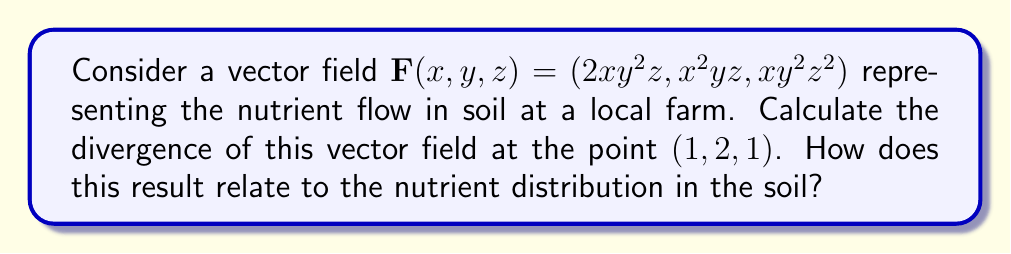Solve this math problem. To solve this problem, we'll follow these steps:

1) The divergence of a vector field $\mathbf{F}(x, y, z) = (F_1, F_2, F_3)$ is given by:

   $$\nabla \cdot \mathbf{F} = \frac{\partial F_1}{\partial x} + \frac{\partial F_2}{\partial y} + \frac{\partial F_3}{\partial z}$$

2) For our vector field $\mathbf{F}(x, y, z) = (2xy^2z, x^2yz, xy^2z^2)$, we need to calculate:

   $$\frac{\partial}{\partial x}(2xy^2z) + \frac{\partial}{\partial y}(x^2yz) + \frac{\partial}{\partial z}(xy^2z^2)$$

3) Let's calculate each partial derivative:

   $\frac{\partial}{\partial x}(2xy^2z) = 2y^2z$
   
   $\frac{\partial}{\partial y}(x^2yz) = x^2z$
   
   $\frac{\partial}{\partial z}(xy^2z^2) = 2xy^2z$

4) Now, we can write the divergence as:

   $$\nabla \cdot \mathbf{F} = 2y^2z + x^2z + 2xy^2z$$

5) To evaluate this at the point $(1, 2, 1)$, we substitute $x=1$, $y=2$, and $z=1$:

   $$\nabla \cdot \mathbf{F}|_{(1,2,1)} = 2(2^2)(1) + (1^2)(1) + 2(1)(2^2)(1) = 8 + 1 + 8 = 17$$

6) Interpretation: The positive divergence indicates that this point is a source of nutrients in the soil. This means that at this location, nutrients are flowing outward, potentially enriching the surrounding soil.
Answer: 17; source of nutrients 